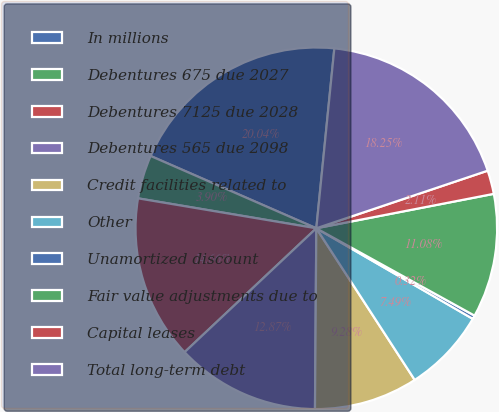Convert chart to OTSL. <chart><loc_0><loc_0><loc_500><loc_500><pie_chart><fcel>In millions<fcel>Debentures 675 due 2027<fcel>Debentures 7125 due 2028<fcel>Debentures 565 due 2098<fcel>Credit facilities related to<fcel>Other<fcel>Unamortized discount<fcel>Fair value adjustments due to<fcel>Capital leases<fcel>Total long-term debt<nl><fcel>20.04%<fcel>3.9%<fcel>14.66%<fcel>12.87%<fcel>9.28%<fcel>7.49%<fcel>0.32%<fcel>11.08%<fcel>2.11%<fcel>18.25%<nl></chart> 